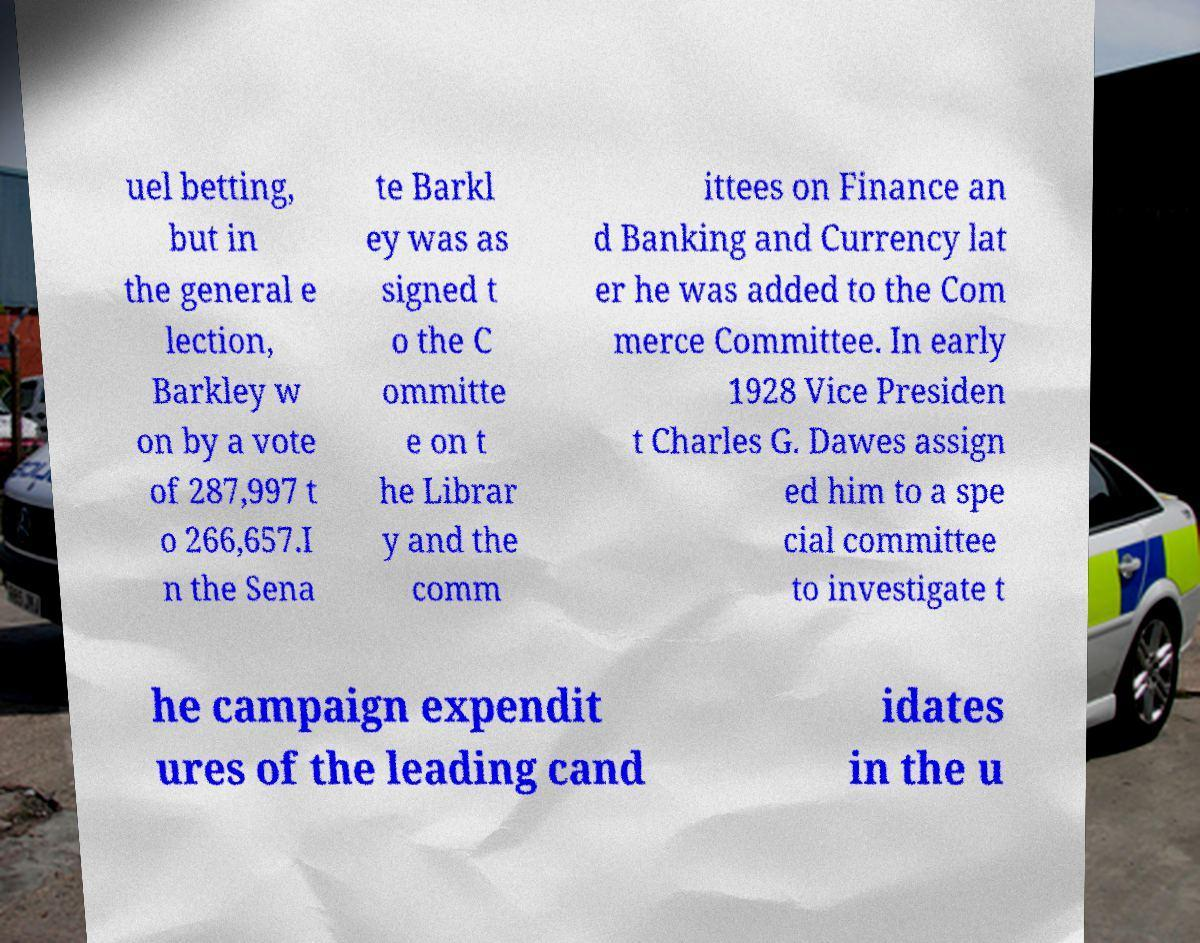Please identify and transcribe the text found in this image. uel betting, but in the general e lection, Barkley w on by a vote of 287,997 t o 266,657.I n the Sena te Barkl ey was as signed t o the C ommitte e on t he Librar y and the comm ittees on Finance an d Banking and Currency lat er he was added to the Com merce Committee. In early 1928 Vice Presiden t Charles G. Dawes assign ed him to a spe cial committee to investigate t he campaign expendit ures of the leading cand idates in the u 